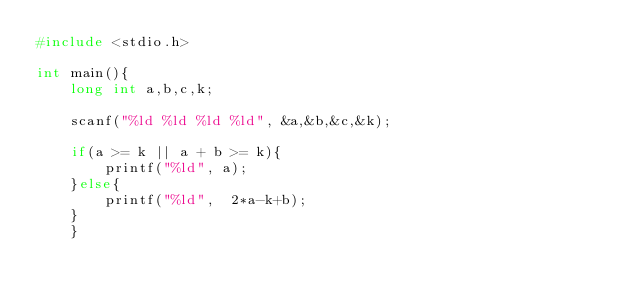<code> <loc_0><loc_0><loc_500><loc_500><_C_>#include <stdio.h>

int main(){
    long int a,b,c,k;
    
    scanf("%ld %ld %ld %ld", &a,&b,&c,&k);

    if(a >= k || a + b >= k){
        printf("%ld", a);
    }else{
        printf("%ld",  2*a-k+b);
    }
    }</code> 